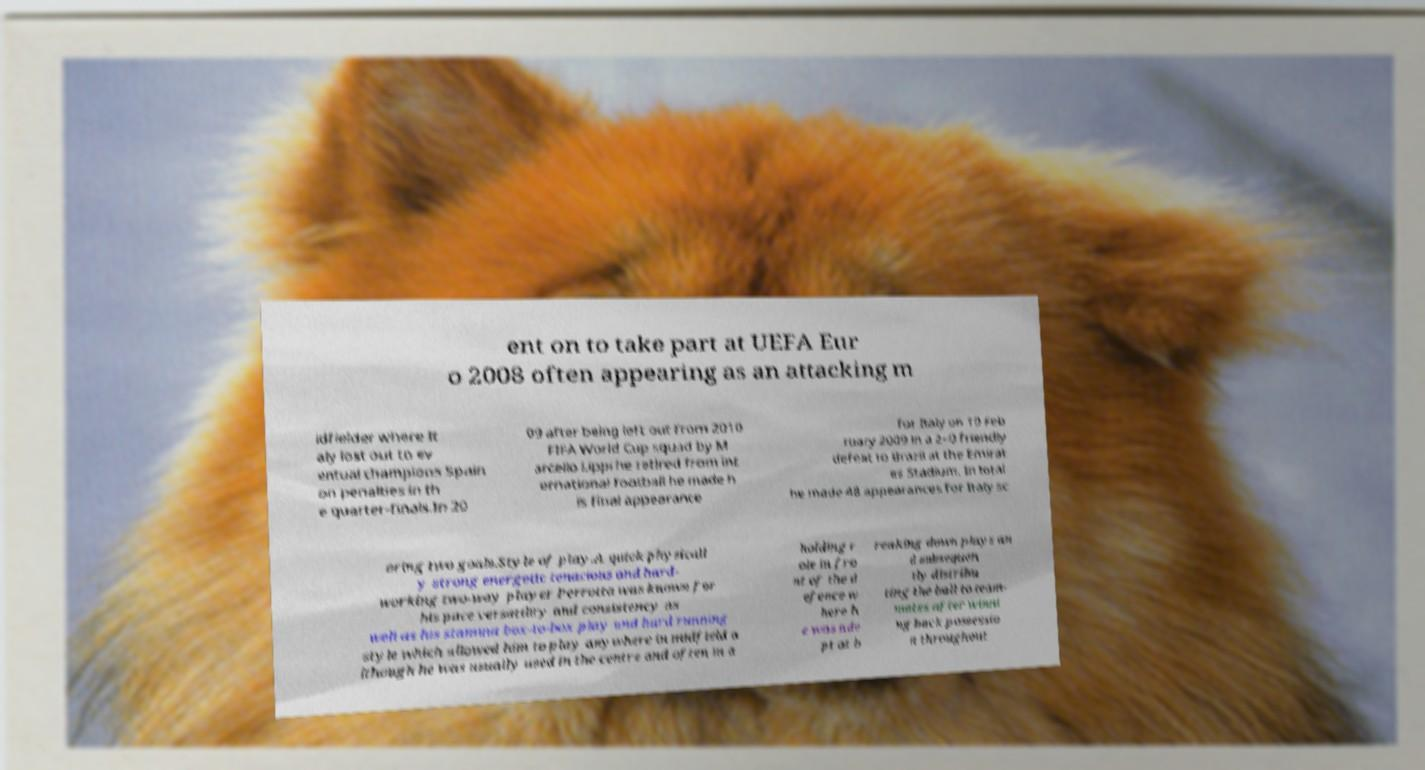For documentation purposes, I need the text within this image transcribed. Could you provide that? ent on to take part at UEFA Eur o 2008 often appearing as an attacking m idfielder where It aly lost out to ev entual champions Spain on penalties in th e quarter-finals.In 20 09 after being left out from 2010 FIFA World Cup squad by M arcello Lippi he retired from int ernational football he made h is final appearance for Italy on 10 Feb ruary 2009 in a 2–0 friendly defeat to Brazil at the Emirat es Stadium. In total he made 48 appearances for Italy sc oring two goals.Style of play.A quick physicall y strong energetic tenacious and hard- working two-way player Perrotta was known for his pace versatility and consistency as well as his stamina box-to-box play and hard running style which allowed him to play anywhere in midfield a lthough he was usually used in the centre and often in a holding r ole in fro nt of the d efence w here h e was ade pt at b reaking down plays an d subsequen tly distribu ting the ball to team- mates after winni ng back possessio n throughout 